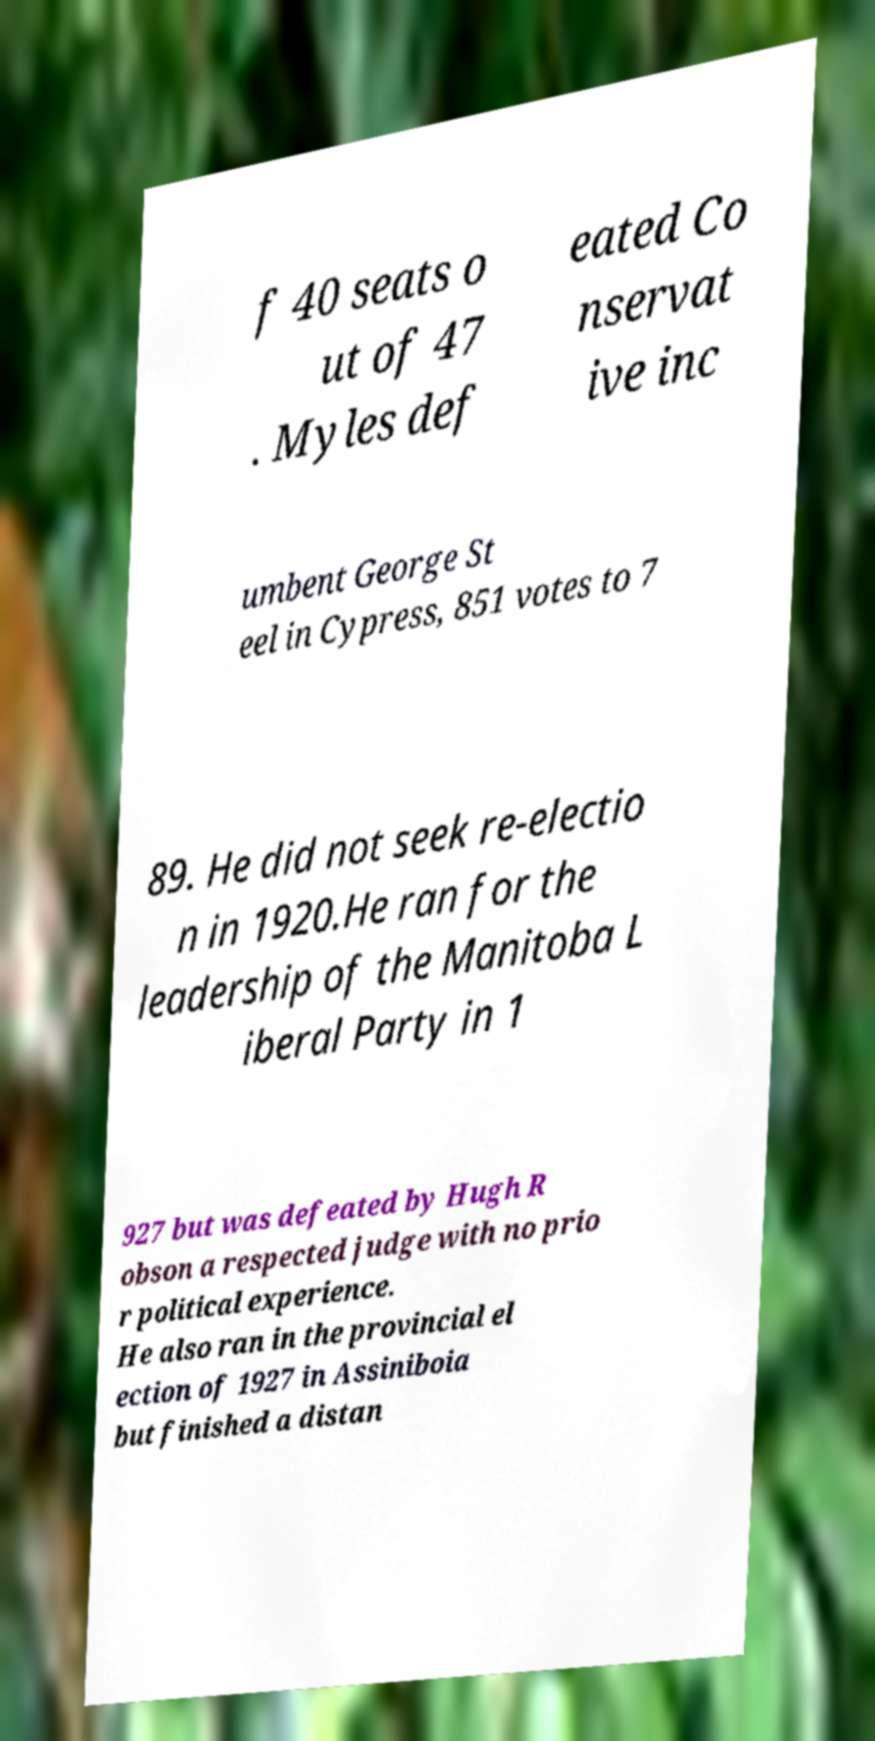Please read and relay the text visible in this image. What does it say? f 40 seats o ut of 47 . Myles def eated Co nservat ive inc umbent George St eel in Cypress, 851 votes to 7 89. He did not seek re-electio n in 1920.He ran for the leadership of the Manitoba L iberal Party in 1 927 but was defeated by Hugh R obson a respected judge with no prio r political experience. He also ran in the provincial el ection of 1927 in Assiniboia but finished a distan 